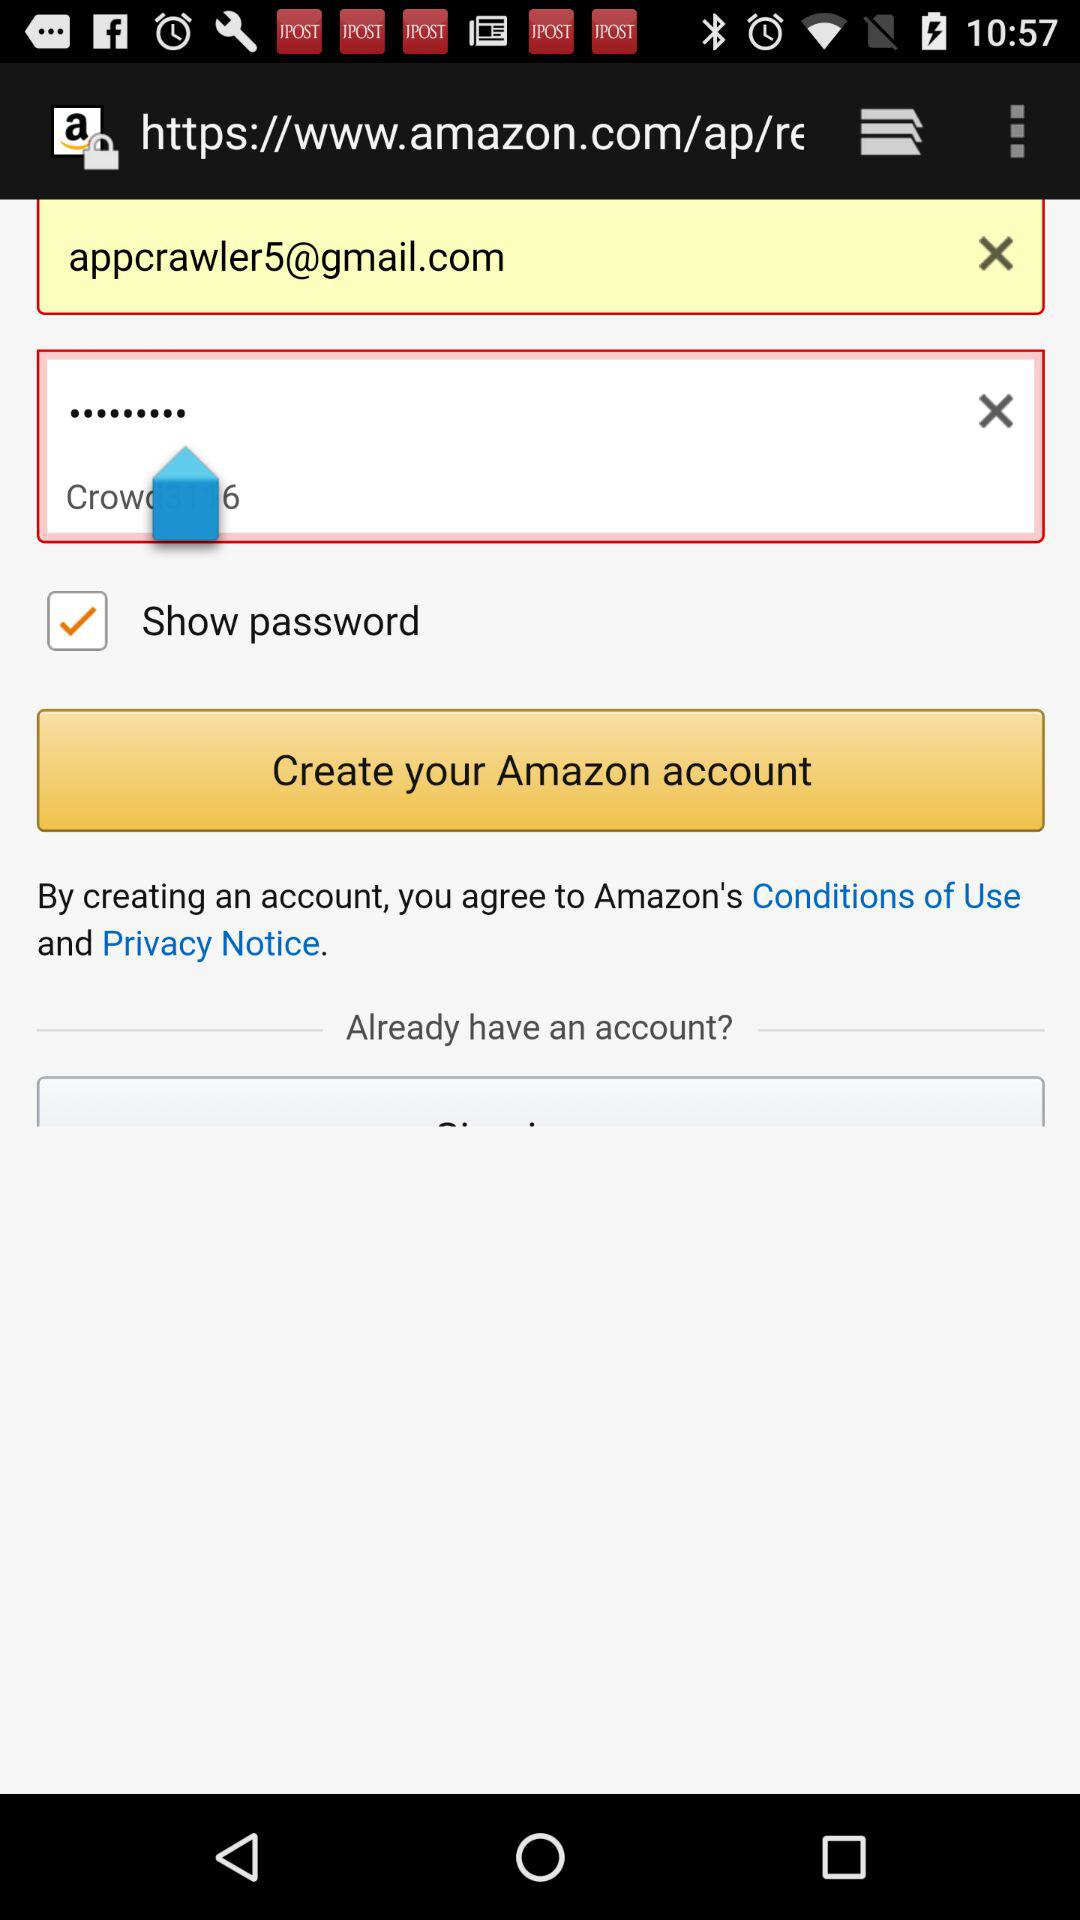What is the status of "Show password"? The status of "Show password" is "on". 